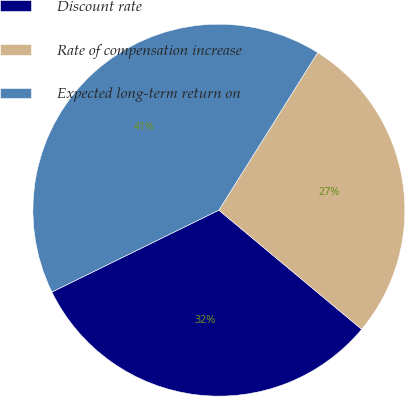<chart> <loc_0><loc_0><loc_500><loc_500><pie_chart><fcel>Discount rate<fcel>Rate of compensation increase<fcel>Expected long-term return on<nl><fcel>31.68%<fcel>27.15%<fcel>41.17%<nl></chart> 